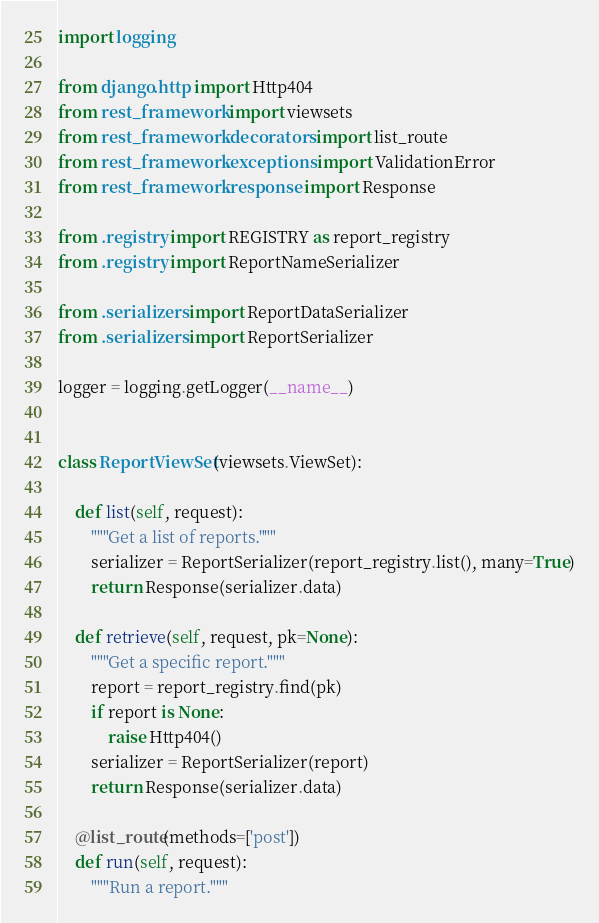<code> <loc_0><loc_0><loc_500><loc_500><_Python_>import logging

from django.http import Http404
from rest_framework import viewsets
from rest_framework.decorators import list_route
from rest_framework.exceptions import ValidationError
from rest_framework.response import Response

from .registry import REGISTRY as report_registry
from .registry import ReportNameSerializer

from .serializers import ReportDataSerializer
from .serializers import ReportSerializer

logger = logging.getLogger(__name__)


class ReportViewSet(viewsets.ViewSet):

    def list(self, request):
        """Get a list of reports."""
        serializer = ReportSerializer(report_registry.list(), many=True)
        return Response(serializer.data)

    def retrieve(self, request, pk=None):
        """Get a specific report."""
        report = report_registry.find(pk)
        if report is None:
            raise Http404()
        serializer = ReportSerializer(report)
        return Response(serializer.data)

    @list_route(methods=['post'])
    def run(self, request):
        """Run a report."""</code> 